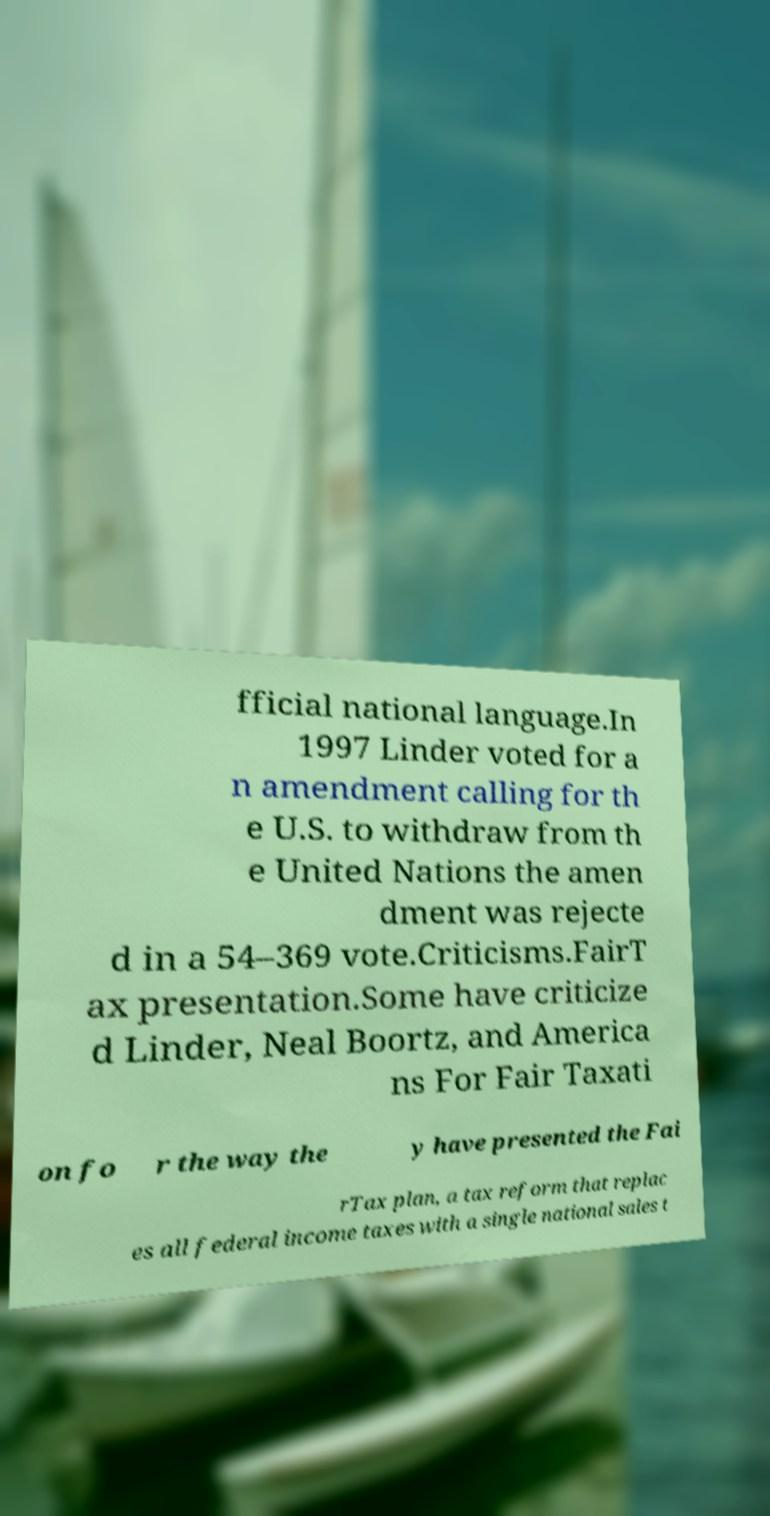What messages or text are displayed in this image? I need them in a readable, typed format. fficial national language.In 1997 Linder voted for a n amendment calling for th e U.S. to withdraw from th e United Nations the amen dment was rejecte d in a 54–369 vote.Criticisms.FairT ax presentation.Some have criticize d Linder, Neal Boortz, and America ns For Fair Taxati on fo r the way the y have presented the Fai rTax plan, a tax reform that replac es all federal income taxes with a single national sales t 